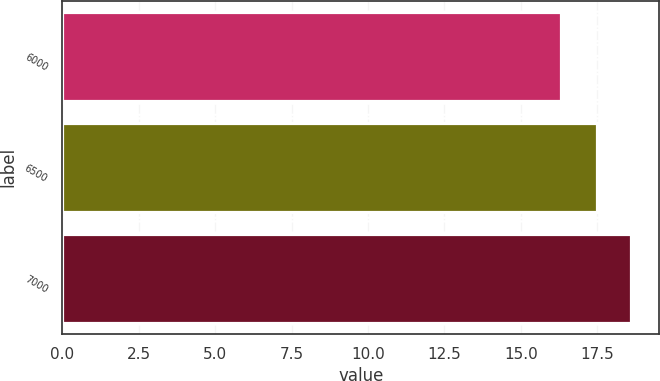Convert chart to OTSL. <chart><loc_0><loc_0><loc_500><loc_500><bar_chart><fcel>6000<fcel>6500<fcel>7000<nl><fcel>16.3<fcel>17.5<fcel>18.6<nl></chart> 